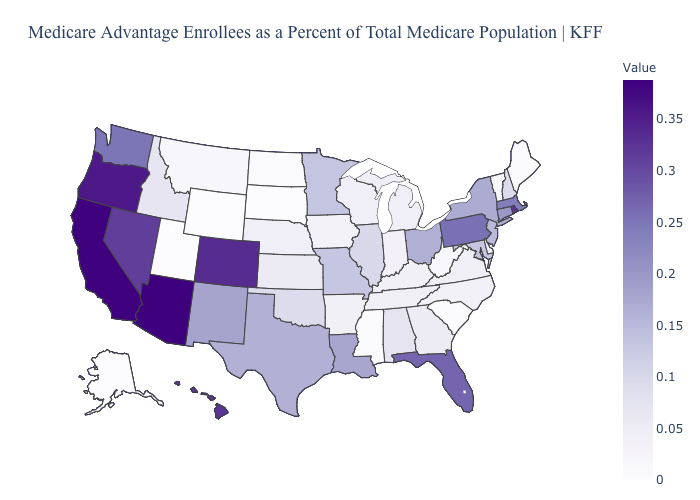Among the states that border Vermont , which have the lowest value?
Keep it brief. New Hampshire. Among the states that border Rhode Island , which have the highest value?
Give a very brief answer. Massachusetts. Which states have the highest value in the USA?
Answer briefly. Arizona. Which states have the lowest value in the USA?
Concise answer only. Alaska, South Dakota, Utah, Wyoming. Is the legend a continuous bar?
Answer briefly. Yes. 